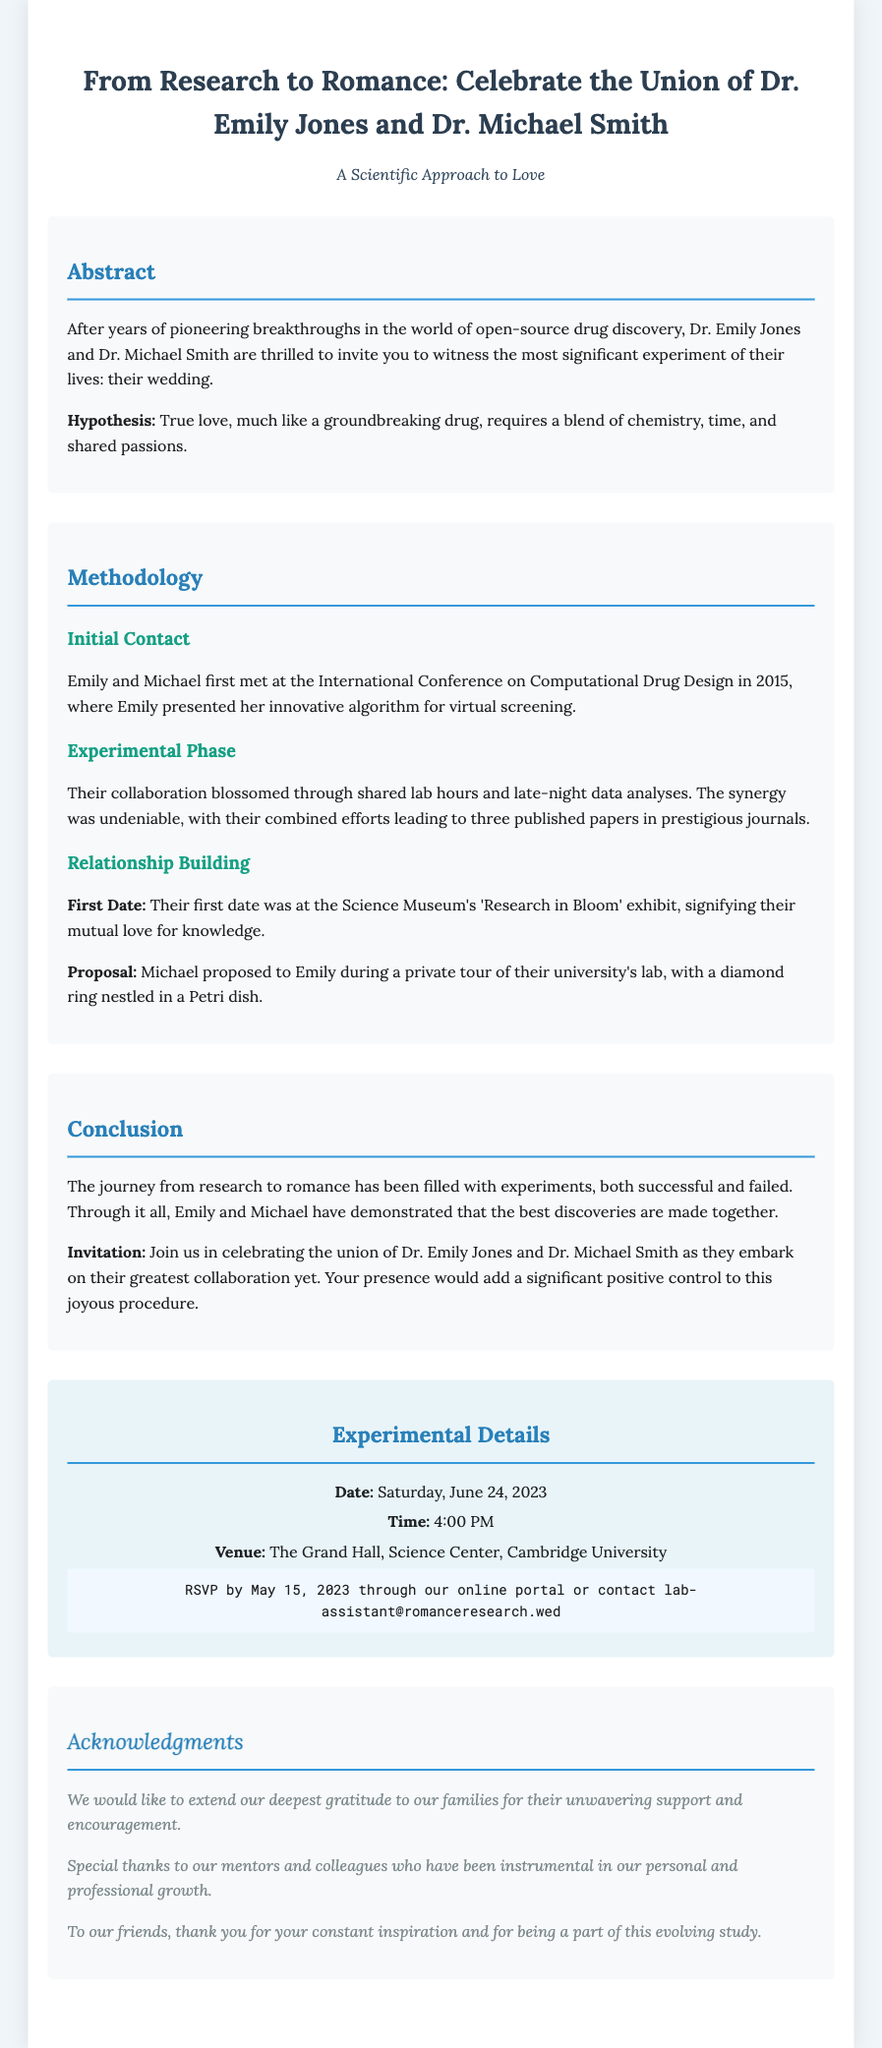what are the names of the couple? The invitation is specifically titled with the names of the couple, "Dr. Emily Jones and Dr. Michael Smith."
Answer: Dr. Emily Jones and Dr. Michael Smith what is the date of the wedding? The date of the wedding is listed under "Experimental Details" section of the invitation, indicating the specific day of the event.
Answer: Saturday, June 24, 2023 where will the wedding take place? The venue is mentioned in the "Experimental Details" section, providing the location of the celebration.
Answer: The Grand Hall, Science Center, Cambridge University what is the hypothesis presented in the abstract? The hypothesis is stated in the Abstract section, summarizing the essential theme of the couple's love story.
Answer: True love requires a blend of chemistry, time, and shared passions what was their first date? The first date is detailed in the "Relationship Building" section, stating the specific location of their first outing.
Answer: Science Museum's 'Research in Bloom' exhibit what type of event is being celebrated? The document's title clearly indicates what type of event is being announced, focusing on the nature of the gathering.
Answer: Wedding how many published papers did they collaborate on? The number of published papers resulting from their collaboration is presented in the "Experimental Phase" section.
Answer: Three who proposed to whom? The invitation describes the proposal details, clarifying who made the proposal during their special moment.
Answer: Michael proposed to Emily what is the RSVP deadline? The RSVP deadline is mentioned in the "Experimental Details" section, providing the last date for responses.
Answer: May 15, 2023 who do they thank in the acknowledgments? The "Acknowledgments" section notes the individuals and groups for whom they express gratitude, referencing their support.
Answer: Their families, mentors, colleagues, and friends 